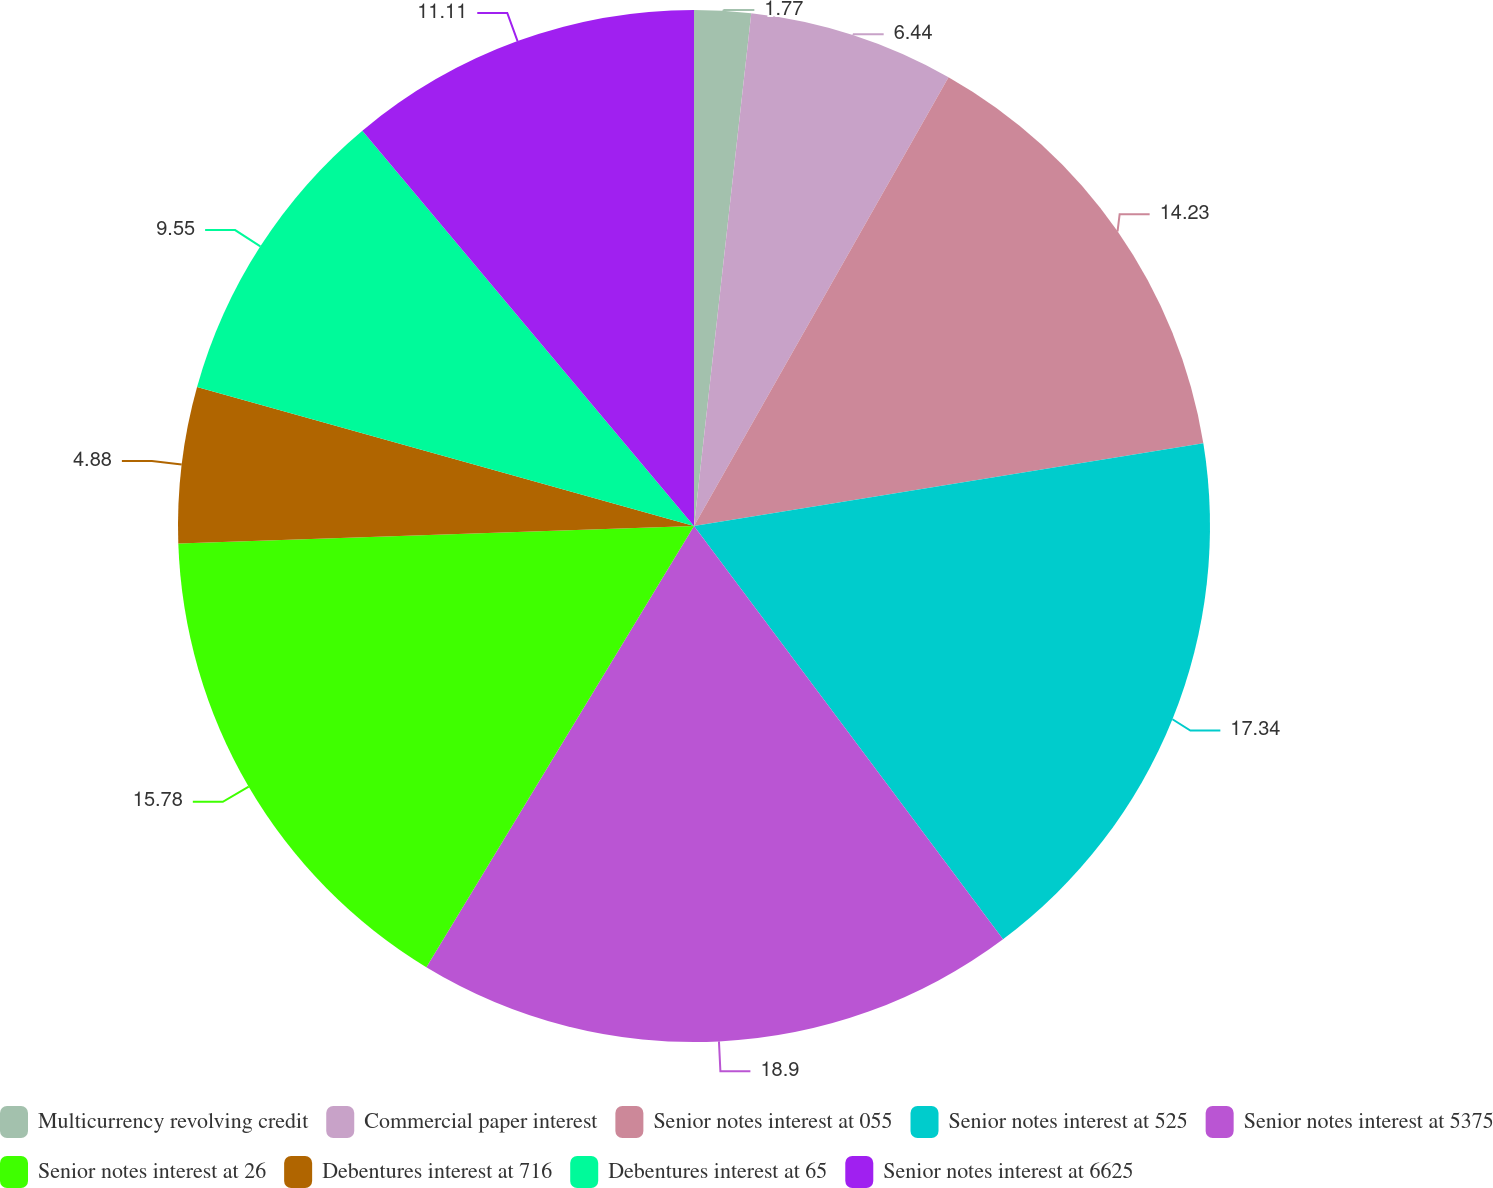<chart> <loc_0><loc_0><loc_500><loc_500><pie_chart><fcel>Multicurrency revolving credit<fcel>Commercial paper interest<fcel>Senior notes interest at 055<fcel>Senior notes interest at 525<fcel>Senior notes interest at 5375<fcel>Senior notes interest at 26<fcel>Debentures interest at 716<fcel>Debentures interest at 65<fcel>Senior notes interest at 6625<nl><fcel>1.77%<fcel>6.44%<fcel>14.23%<fcel>17.34%<fcel>18.9%<fcel>15.78%<fcel>4.88%<fcel>9.55%<fcel>11.11%<nl></chart> 